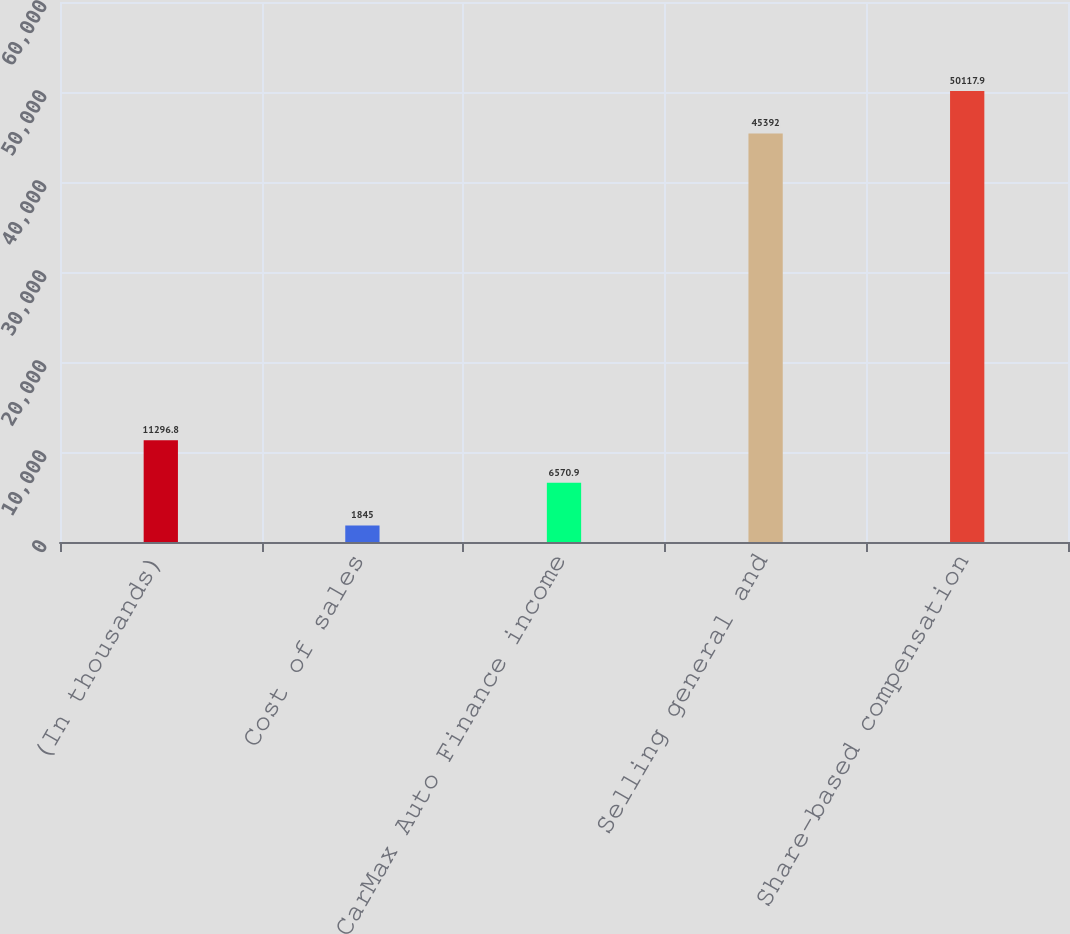Convert chart. <chart><loc_0><loc_0><loc_500><loc_500><bar_chart><fcel>(In thousands)<fcel>Cost of sales<fcel>CarMax Auto Finance income<fcel>Selling general and<fcel>Share-based compensation<nl><fcel>11296.8<fcel>1845<fcel>6570.9<fcel>45392<fcel>50117.9<nl></chart> 